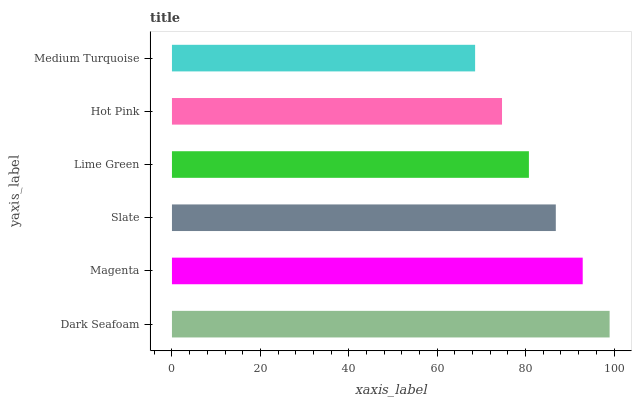Is Medium Turquoise the minimum?
Answer yes or no. Yes. Is Dark Seafoam the maximum?
Answer yes or no. Yes. Is Magenta the minimum?
Answer yes or no. No. Is Magenta the maximum?
Answer yes or no. No. Is Dark Seafoam greater than Magenta?
Answer yes or no. Yes. Is Magenta less than Dark Seafoam?
Answer yes or no. Yes. Is Magenta greater than Dark Seafoam?
Answer yes or no. No. Is Dark Seafoam less than Magenta?
Answer yes or no. No. Is Slate the high median?
Answer yes or no. Yes. Is Lime Green the low median?
Answer yes or no. Yes. Is Dark Seafoam the high median?
Answer yes or no. No. Is Slate the low median?
Answer yes or no. No. 